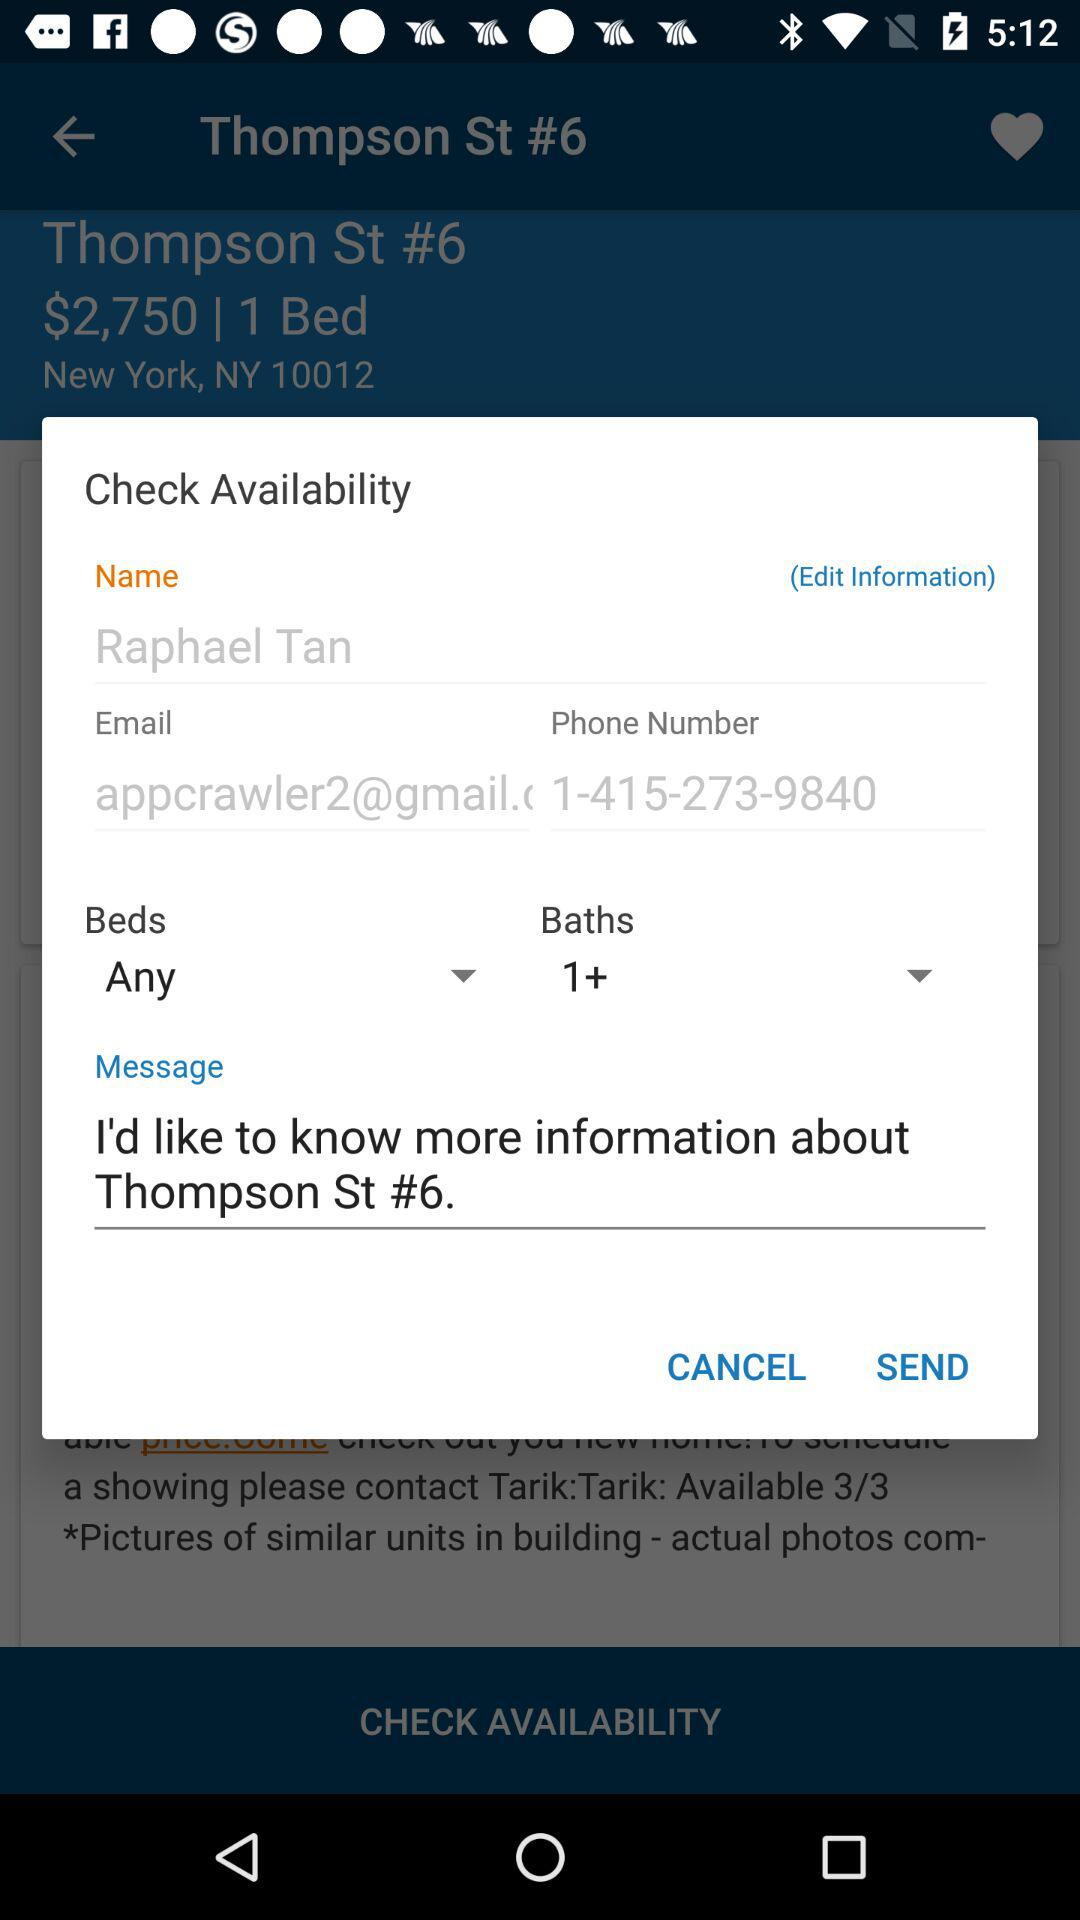What email address has been given? The email address that has been given is "appcrawler2@gmail.". 